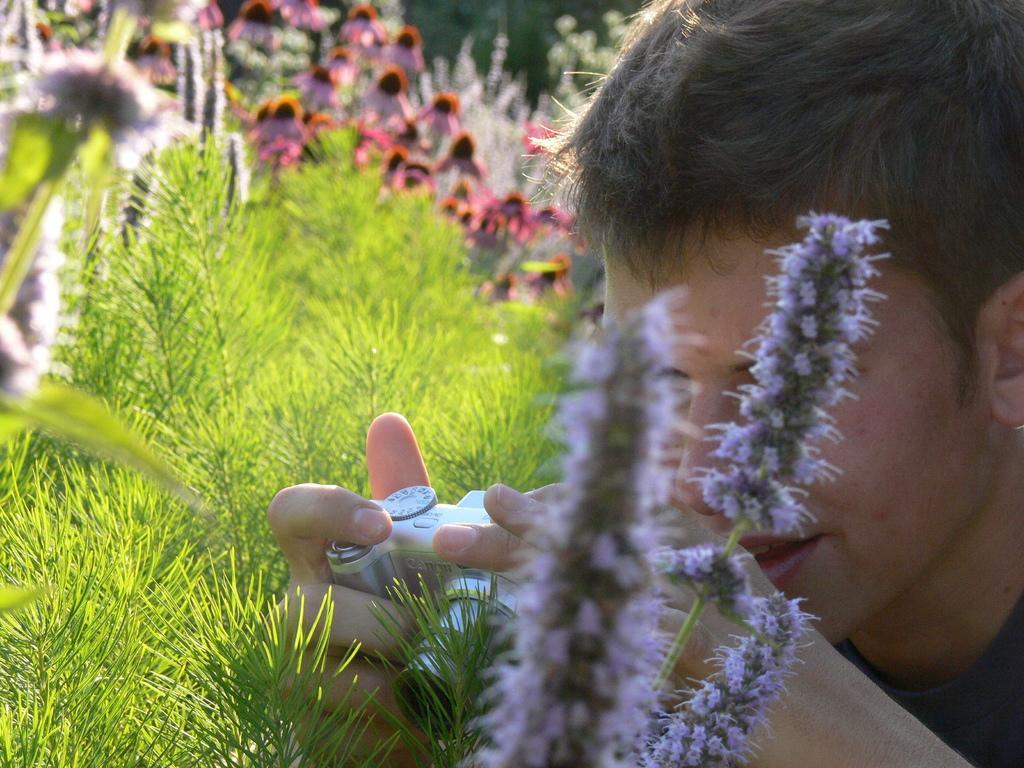Please provide a concise description of this image. In this image I can see flowers, grass in the front and in the background of this image. I can also see a man on the right side and I can see he is holding a camera. 